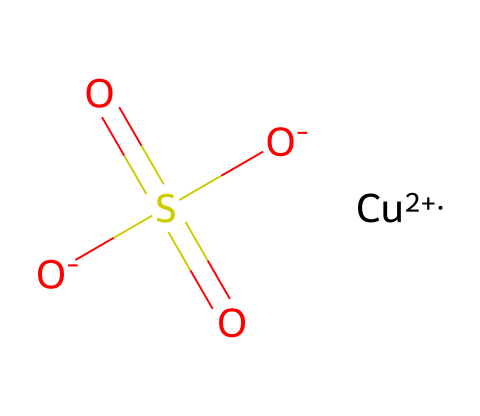What is the oxidation state of copper in this compound? In the given SMILES representation, copper is indicated with the symbol [Cu+2], which signifies that copper has an oxidation state of +2.
Answer: +2 How many oxygen atoms are present in this molecule? The SMILES notation indicates three oxygen atoms present in the sulfate group (S(=O)(=O)[O-]) and does not specify any additional oxygen atoms. Thus, there are three oxygen atoms in total.
Answer: 4 What type of pesticide is indicated by this chemical? This chemical is a fungicide and algaecide, which indicates its function as a pesticide, particularly for eliminating fungi and algae in water.
Answer: fungicide and algaecide Which functional group is responsible for its toxicity? The sulfate group is indicative of the compound's mechanism in disrupting cellular processes, contributing to its fungicidal and algicidal properties.
Answer: sulfate group How many total atoms are in this molecule? Counting the constituents from the SMILES: 1 copper (Cu), 1 sulfur (S), and 4 oxygen (O) gives a total of 6 atoms.
Answer: 6 What element in this compound allows it to function as a metal-based pesticide? The presence of copper is critical, as it is a metal that provides the compound with its toxicological properties against certain pests.
Answer: copper 